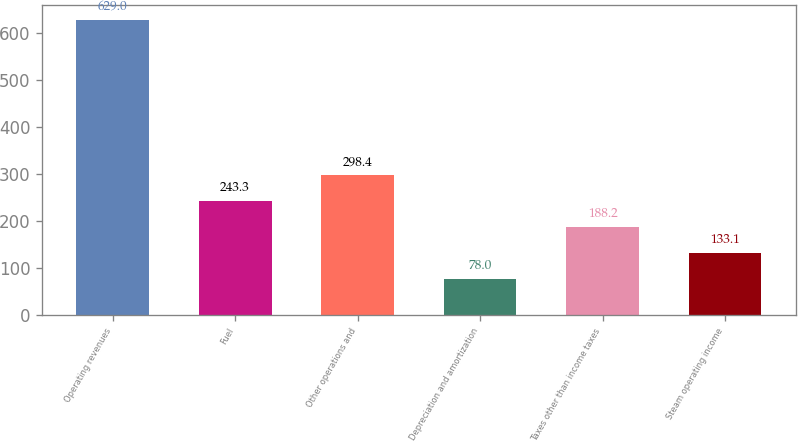Convert chart to OTSL. <chart><loc_0><loc_0><loc_500><loc_500><bar_chart><fcel>Operating revenues<fcel>Fuel<fcel>Other operations and<fcel>Depreciation and amortization<fcel>Taxes other than income taxes<fcel>Steam operating income<nl><fcel>629<fcel>243.3<fcel>298.4<fcel>78<fcel>188.2<fcel>133.1<nl></chart> 